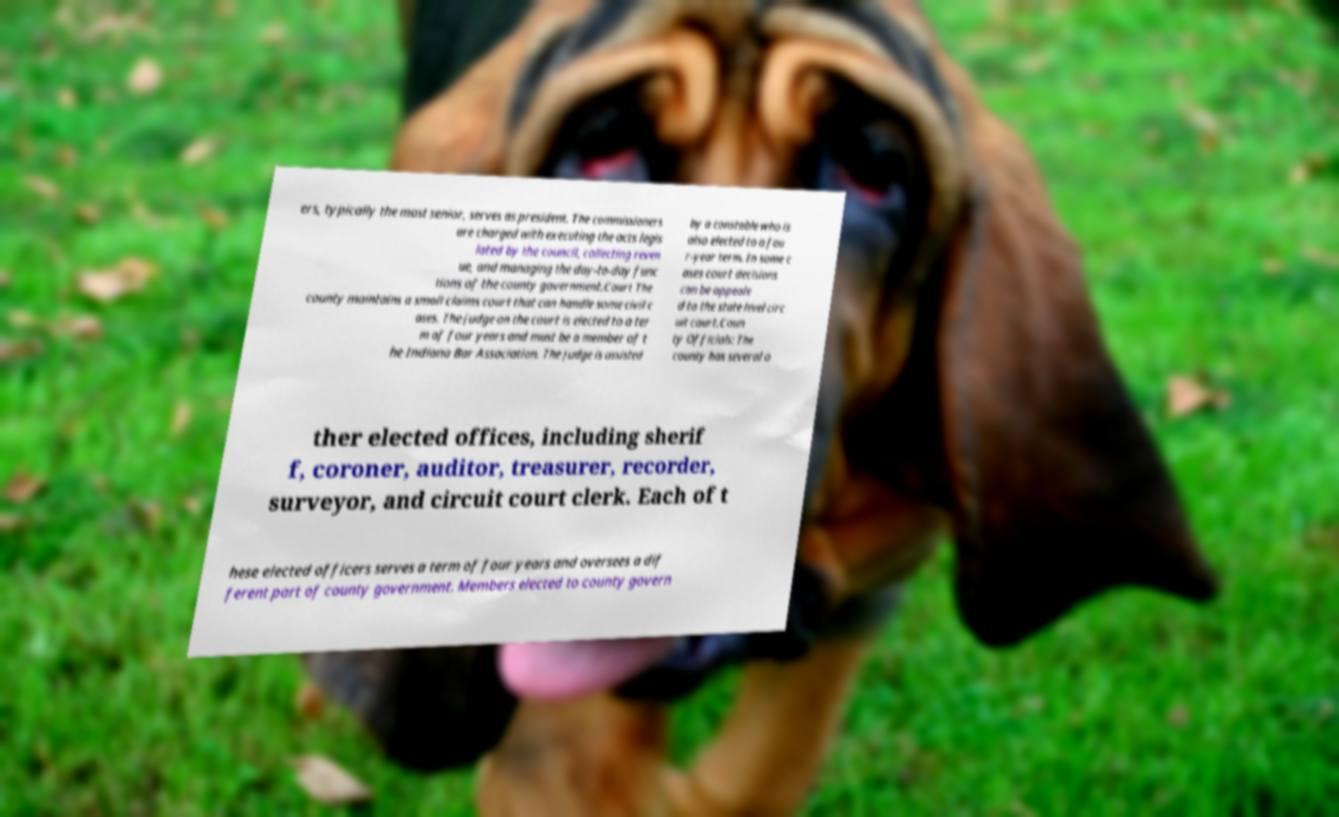Can you accurately transcribe the text from the provided image for me? ers, typically the most senior, serves as president. The commissioners are charged with executing the acts legis lated by the council, collecting reven ue, and managing the day-to-day func tions of the county government.Court The county maintains a small claims court that can handle some civil c ases. The judge on the court is elected to a ter m of four years and must be a member of t he Indiana Bar Association. The judge is assisted by a constable who is also elected to a fou r-year term. In some c ases court decisions can be appeale d to the state level circ uit court.Coun ty Officials: The county has several o ther elected offices, including sherif f, coroner, auditor, treasurer, recorder, surveyor, and circuit court clerk. Each of t hese elected officers serves a term of four years and oversees a dif ferent part of county government. Members elected to county govern 